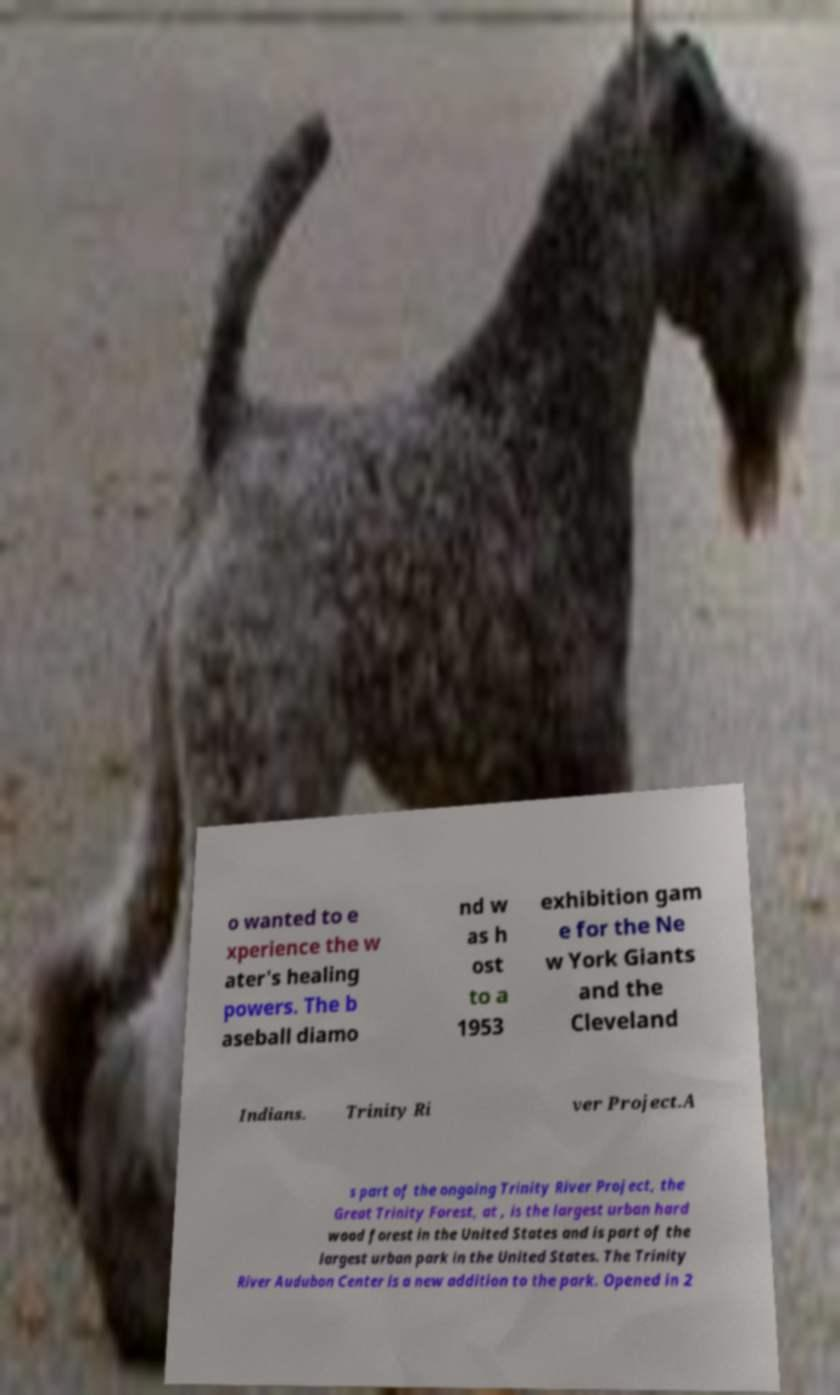Can you read and provide the text displayed in the image?This photo seems to have some interesting text. Can you extract and type it out for me? o wanted to e xperience the w ater's healing powers. The b aseball diamo nd w as h ost to a 1953 exhibition gam e for the Ne w York Giants and the Cleveland Indians. Trinity Ri ver Project.A s part of the ongoing Trinity River Project, the Great Trinity Forest, at , is the largest urban hard wood forest in the United States and is part of the largest urban park in the United States. The Trinity River Audubon Center is a new addition to the park. Opened in 2 